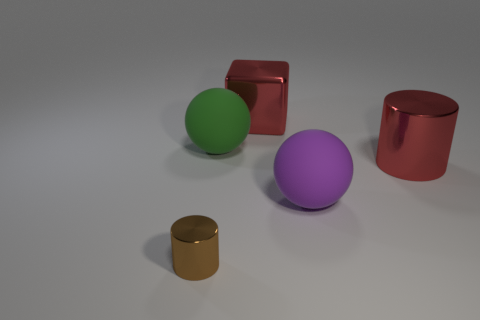Add 2 objects. How many objects exist? 7 Subtract all green balls. How many balls are left? 1 Subtract all cubes. How many objects are left? 4 Add 2 brown things. How many brown things are left? 3 Add 3 tiny blocks. How many tiny blocks exist? 3 Subtract 0 brown cubes. How many objects are left? 5 Subtract all yellow spheres. Subtract all blue cylinders. How many spheres are left? 2 Subtract all red cubes. Subtract all big purple spheres. How many objects are left? 3 